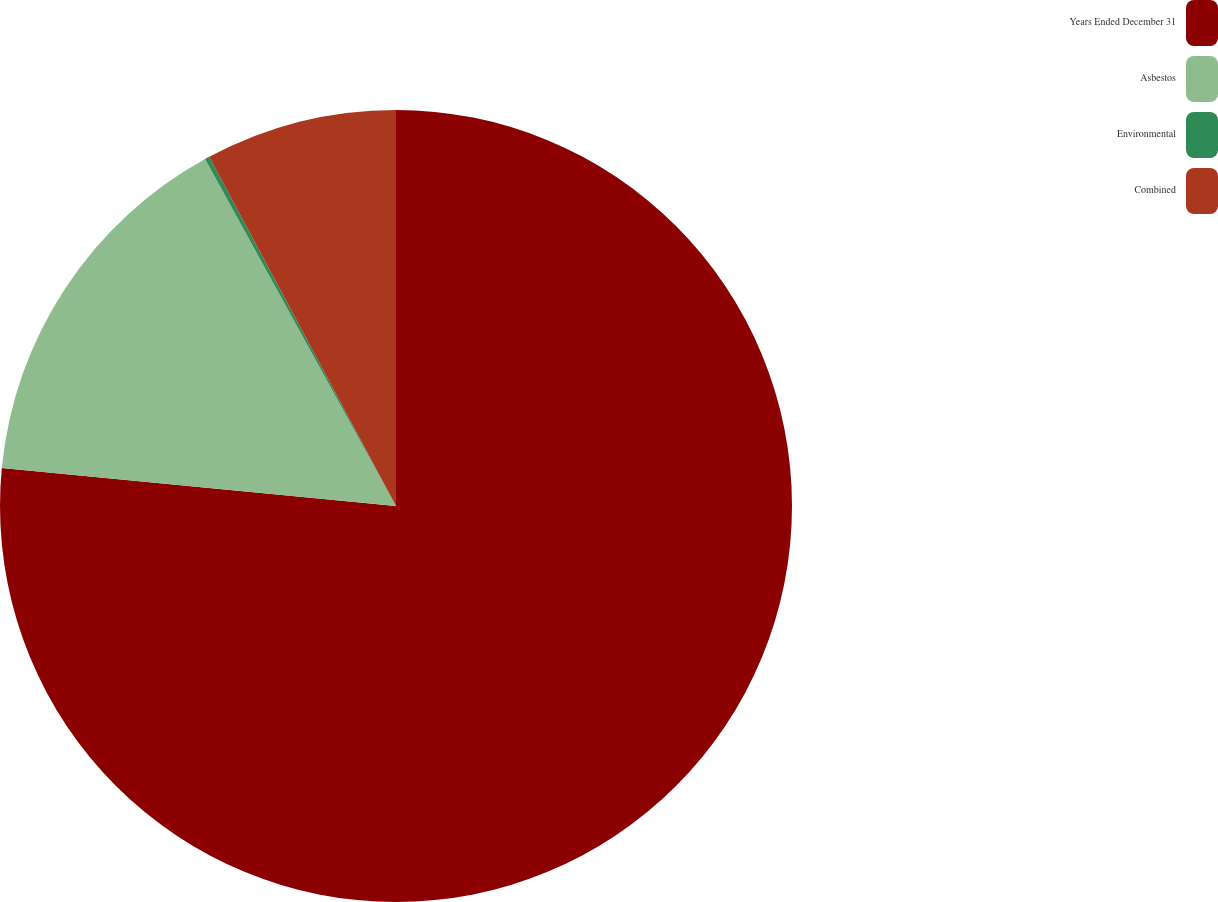<chart> <loc_0><loc_0><loc_500><loc_500><pie_chart><fcel>Years Ended December 31<fcel>Asbestos<fcel>Environmental<fcel>Combined<nl><fcel>76.53%<fcel>15.46%<fcel>0.19%<fcel>7.82%<nl></chart> 